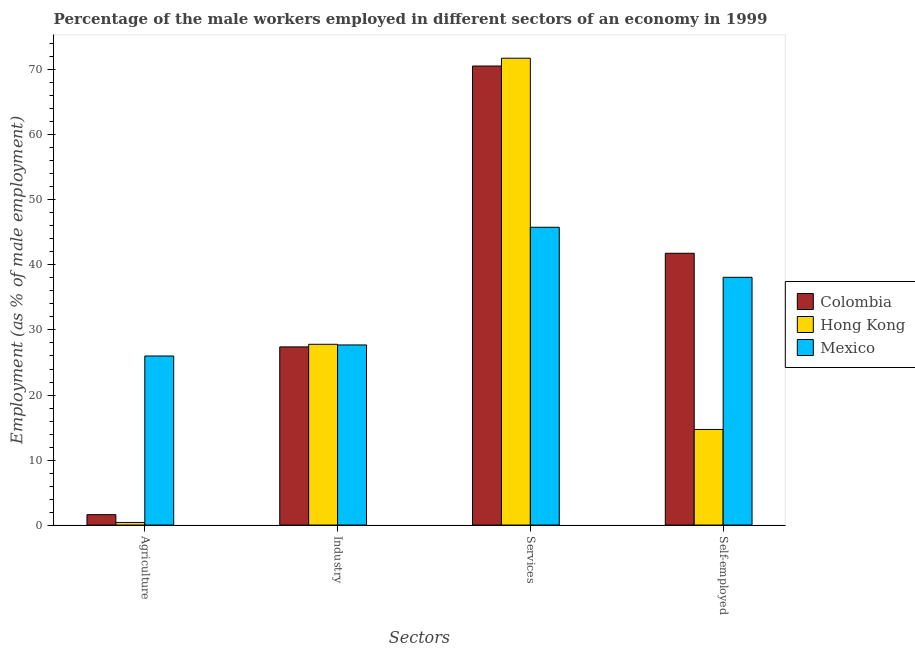How many groups of bars are there?
Your answer should be compact. 4. Are the number of bars per tick equal to the number of legend labels?
Offer a very short reply. Yes. Are the number of bars on each tick of the X-axis equal?
Your answer should be very brief. Yes. How many bars are there on the 2nd tick from the right?
Make the answer very short. 3. What is the label of the 2nd group of bars from the left?
Offer a very short reply. Industry. What is the percentage of male workers in industry in Colombia?
Your answer should be very brief. 27.4. Across all countries, what is the maximum percentage of male workers in industry?
Provide a short and direct response. 27.8. Across all countries, what is the minimum percentage of male workers in agriculture?
Offer a terse response. 0.4. In which country was the percentage of male workers in services maximum?
Offer a very short reply. Hong Kong. In which country was the percentage of self employed male workers minimum?
Keep it short and to the point. Hong Kong. What is the total percentage of male workers in services in the graph?
Your answer should be very brief. 188.2. What is the difference between the percentage of male workers in agriculture in Colombia and that in Hong Kong?
Your answer should be very brief. 1.2. What is the difference between the percentage of male workers in services in Hong Kong and the percentage of male workers in industry in Mexico?
Offer a very short reply. 44.1. What is the average percentage of male workers in industry per country?
Your response must be concise. 27.63. What is the difference between the percentage of self employed male workers and percentage of male workers in industry in Colombia?
Ensure brevity in your answer.  14.4. In how many countries, is the percentage of male workers in industry greater than 38 %?
Your answer should be compact. 0. What is the ratio of the percentage of male workers in industry in Colombia to that in Hong Kong?
Give a very brief answer. 0.99. Is the percentage of male workers in services in Colombia less than that in Mexico?
Offer a terse response. No. Is the difference between the percentage of male workers in industry in Colombia and Mexico greater than the difference between the percentage of male workers in agriculture in Colombia and Mexico?
Offer a terse response. Yes. What is the difference between the highest and the second highest percentage of male workers in agriculture?
Give a very brief answer. 24.4. What is the difference between the highest and the lowest percentage of self employed male workers?
Your response must be concise. 27.1. Is the sum of the percentage of self employed male workers in Colombia and Mexico greater than the maximum percentage of male workers in services across all countries?
Offer a very short reply. Yes. How many bars are there?
Your response must be concise. 12. Are all the bars in the graph horizontal?
Your answer should be compact. No. Are the values on the major ticks of Y-axis written in scientific E-notation?
Offer a very short reply. No. Does the graph contain any zero values?
Ensure brevity in your answer.  No. Does the graph contain grids?
Your response must be concise. No. Where does the legend appear in the graph?
Your response must be concise. Center right. How many legend labels are there?
Your answer should be compact. 3. How are the legend labels stacked?
Your answer should be very brief. Vertical. What is the title of the graph?
Ensure brevity in your answer.  Percentage of the male workers employed in different sectors of an economy in 1999. What is the label or title of the X-axis?
Give a very brief answer. Sectors. What is the label or title of the Y-axis?
Give a very brief answer. Employment (as % of male employment). What is the Employment (as % of male employment) in Colombia in Agriculture?
Keep it short and to the point. 1.6. What is the Employment (as % of male employment) in Hong Kong in Agriculture?
Your answer should be compact. 0.4. What is the Employment (as % of male employment) of Mexico in Agriculture?
Offer a terse response. 26. What is the Employment (as % of male employment) in Colombia in Industry?
Offer a terse response. 27.4. What is the Employment (as % of male employment) of Hong Kong in Industry?
Provide a short and direct response. 27.8. What is the Employment (as % of male employment) of Mexico in Industry?
Make the answer very short. 27.7. What is the Employment (as % of male employment) of Colombia in Services?
Offer a very short reply. 70.6. What is the Employment (as % of male employment) in Hong Kong in Services?
Provide a short and direct response. 71.8. What is the Employment (as % of male employment) in Mexico in Services?
Ensure brevity in your answer.  45.8. What is the Employment (as % of male employment) of Colombia in Self-employed?
Provide a short and direct response. 41.8. What is the Employment (as % of male employment) of Hong Kong in Self-employed?
Offer a terse response. 14.7. What is the Employment (as % of male employment) in Mexico in Self-employed?
Your response must be concise. 38.1. Across all Sectors, what is the maximum Employment (as % of male employment) in Colombia?
Provide a succinct answer. 70.6. Across all Sectors, what is the maximum Employment (as % of male employment) in Hong Kong?
Make the answer very short. 71.8. Across all Sectors, what is the maximum Employment (as % of male employment) in Mexico?
Provide a short and direct response. 45.8. Across all Sectors, what is the minimum Employment (as % of male employment) of Colombia?
Offer a very short reply. 1.6. Across all Sectors, what is the minimum Employment (as % of male employment) of Hong Kong?
Provide a succinct answer. 0.4. What is the total Employment (as % of male employment) of Colombia in the graph?
Give a very brief answer. 141.4. What is the total Employment (as % of male employment) in Hong Kong in the graph?
Give a very brief answer. 114.7. What is the total Employment (as % of male employment) of Mexico in the graph?
Ensure brevity in your answer.  137.6. What is the difference between the Employment (as % of male employment) of Colombia in Agriculture and that in Industry?
Your answer should be very brief. -25.8. What is the difference between the Employment (as % of male employment) of Hong Kong in Agriculture and that in Industry?
Give a very brief answer. -27.4. What is the difference between the Employment (as % of male employment) in Colombia in Agriculture and that in Services?
Make the answer very short. -69. What is the difference between the Employment (as % of male employment) in Hong Kong in Agriculture and that in Services?
Keep it short and to the point. -71.4. What is the difference between the Employment (as % of male employment) in Mexico in Agriculture and that in Services?
Give a very brief answer. -19.8. What is the difference between the Employment (as % of male employment) of Colombia in Agriculture and that in Self-employed?
Your answer should be compact. -40.2. What is the difference between the Employment (as % of male employment) in Hong Kong in Agriculture and that in Self-employed?
Your answer should be compact. -14.3. What is the difference between the Employment (as % of male employment) in Colombia in Industry and that in Services?
Your answer should be compact. -43.2. What is the difference between the Employment (as % of male employment) in Hong Kong in Industry and that in Services?
Ensure brevity in your answer.  -44. What is the difference between the Employment (as % of male employment) in Mexico in Industry and that in Services?
Provide a short and direct response. -18.1. What is the difference between the Employment (as % of male employment) of Colombia in Industry and that in Self-employed?
Make the answer very short. -14.4. What is the difference between the Employment (as % of male employment) in Hong Kong in Industry and that in Self-employed?
Ensure brevity in your answer.  13.1. What is the difference between the Employment (as % of male employment) of Mexico in Industry and that in Self-employed?
Provide a succinct answer. -10.4. What is the difference between the Employment (as % of male employment) in Colombia in Services and that in Self-employed?
Your response must be concise. 28.8. What is the difference between the Employment (as % of male employment) in Hong Kong in Services and that in Self-employed?
Give a very brief answer. 57.1. What is the difference between the Employment (as % of male employment) in Colombia in Agriculture and the Employment (as % of male employment) in Hong Kong in Industry?
Give a very brief answer. -26.2. What is the difference between the Employment (as % of male employment) in Colombia in Agriculture and the Employment (as % of male employment) in Mexico in Industry?
Your answer should be compact. -26.1. What is the difference between the Employment (as % of male employment) of Hong Kong in Agriculture and the Employment (as % of male employment) of Mexico in Industry?
Offer a terse response. -27.3. What is the difference between the Employment (as % of male employment) in Colombia in Agriculture and the Employment (as % of male employment) in Hong Kong in Services?
Provide a succinct answer. -70.2. What is the difference between the Employment (as % of male employment) in Colombia in Agriculture and the Employment (as % of male employment) in Mexico in Services?
Provide a succinct answer. -44.2. What is the difference between the Employment (as % of male employment) of Hong Kong in Agriculture and the Employment (as % of male employment) of Mexico in Services?
Provide a succinct answer. -45.4. What is the difference between the Employment (as % of male employment) in Colombia in Agriculture and the Employment (as % of male employment) in Mexico in Self-employed?
Ensure brevity in your answer.  -36.5. What is the difference between the Employment (as % of male employment) of Hong Kong in Agriculture and the Employment (as % of male employment) of Mexico in Self-employed?
Offer a very short reply. -37.7. What is the difference between the Employment (as % of male employment) in Colombia in Industry and the Employment (as % of male employment) in Hong Kong in Services?
Provide a succinct answer. -44.4. What is the difference between the Employment (as % of male employment) of Colombia in Industry and the Employment (as % of male employment) of Mexico in Services?
Your response must be concise. -18.4. What is the difference between the Employment (as % of male employment) in Colombia in Industry and the Employment (as % of male employment) in Mexico in Self-employed?
Make the answer very short. -10.7. What is the difference between the Employment (as % of male employment) in Colombia in Services and the Employment (as % of male employment) in Hong Kong in Self-employed?
Your answer should be compact. 55.9. What is the difference between the Employment (as % of male employment) in Colombia in Services and the Employment (as % of male employment) in Mexico in Self-employed?
Provide a succinct answer. 32.5. What is the difference between the Employment (as % of male employment) in Hong Kong in Services and the Employment (as % of male employment) in Mexico in Self-employed?
Provide a succinct answer. 33.7. What is the average Employment (as % of male employment) of Colombia per Sectors?
Your response must be concise. 35.35. What is the average Employment (as % of male employment) of Hong Kong per Sectors?
Your response must be concise. 28.68. What is the average Employment (as % of male employment) of Mexico per Sectors?
Make the answer very short. 34.4. What is the difference between the Employment (as % of male employment) in Colombia and Employment (as % of male employment) in Mexico in Agriculture?
Provide a short and direct response. -24.4. What is the difference between the Employment (as % of male employment) of Hong Kong and Employment (as % of male employment) of Mexico in Agriculture?
Provide a short and direct response. -25.6. What is the difference between the Employment (as % of male employment) in Colombia and Employment (as % of male employment) in Mexico in Industry?
Make the answer very short. -0.3. What is the difference between the Employment (as % of male employment) in Colombia and Employment (as % of male employment) in Hong Kong in Services?
Your response must be concise. -1.2. What is the difference between the Employment (as % of male employment) in Colombia and Employment (as % of male employment) in Mexico in Services?
Keep it short and to the point. 24.8. What is the difference between the Employment (as % of male employment) in Hong Kong and Employment (as % of male employment) in Mexico in Services?
Provide a succinct answer. 26. What is the difference between the Employment (as % of male employment) of Colombia and Employment (as % of male employment) of Hong Kong in Self-employed?
Ensure brevity in your answer.  27.1. What is the difference between the Employment (as % of male employment) in Hong Kong and Employment (as % of male employment) in Mexico in Self-employed?
Your response must be concise. -23.4. What is the ratio of the Employment (as % of male employment) of Colombia in Agriculture to that in Industry?
Offer a very short reply. 0.06. What is the ratio of the Employment (as % of male employment) in Hong Kong in Agriculture to that in Industry?
Your answer should be compact. 0.01. What is the ratio of the Employment (as % of male employment) of Mexico in Agriculture to that in Industry?
Your answer should be compact. 0.94. What is the ratio of the Employment (as % of male employment) of Colombia in Agriculture to that in Services?
Offer a very short reply. 0.02. What is the ratio of the Employment (as % of male employment) of Hong Kong in Agriculture to that in Services?
Your response must be concise. 0.01. What is the ratio of the Employment (as % of male employment) of Mexico in Agriculture to that in Services?
Provide a succinct answer. 0.57. What is the ratio of the Employment (as % of male employment) in Colombia in Agriculture to that in Self-employed?
Ensure brevity in your answer.  0.04. What is the ratio of the Employment (as % of male employment) in Hong Kong in Agriculture to that in Self-employed?
Provide a succinct answer. 0.03. What is the ratio of the Employment (as % of male employment) in Mexico in Agriculture to that in Self-employed?
Your answer should be very brief. 0.68. What is the ratio of the Employment (as % of male employment) of Colombia in Industry to that in Services?
Your response must be concise. 0.39. What is the ratio of the Employment (as % of male employment) of Hong Kong in Industry to that in Services?
Provide a succinct answer. 0.39. What is the ratio of the Employment (as % of male employment) of Mexico in Industry to that in Services?
Ensure brevity in your answer.  0.6. What is the ratio of the Employment (as % of male employment) of Colombia in Industry to that in Self-employed?
Your answer should be compact. 0.66. What is the ratio of the Employment (as % of male employment) of Hong Kong in Industry to that in Self-employed?
Give a very brief answer. 1.89. What is the ratio of the Employment (as % of male employment) of Mexico in Industry to that in Self-employed?
Your answer should be compact. 0.73. What is the ratio of the Employment (as % of male employment) in Colombia in Services to that in Self-employed?
Your response must be concise. 1.69. What is the ratio of the Employment (as % of male employment) of Hong Kong in Services to that in Self-employed?
Your answer should be compact. 4.88. What is the ratio of the Employment (as % of male employment) in Mexico in Services to that in Self-employed?
Your answer should be very brief. 1.2. What is the difference between the highest and the second highest Employment (as % of male employment) of Colombia?
Offer a very short reply. 28.8. What is the difference between the highest and the second highest Employment (as % of male employment) in Hong Kong?
Give a very brief answer. 44. What is the difference between the highest and the second highest Employment (as % of male employment) in Mexico?
Keep it short and to the point. 7.7. What is the difference between the highest and the lowest Employment (as % of male employment) of Colombia?
Give a very brief answer. 69. What is the difference between the highest and the lowest Employment (as % of male employment) in Hong Kong?
Ensure brevity in your answer.  71.4. What is the difference between the highest and the lowest Employment (as % of male employment) in Mexico?
Your response must be concise. 19.8. 